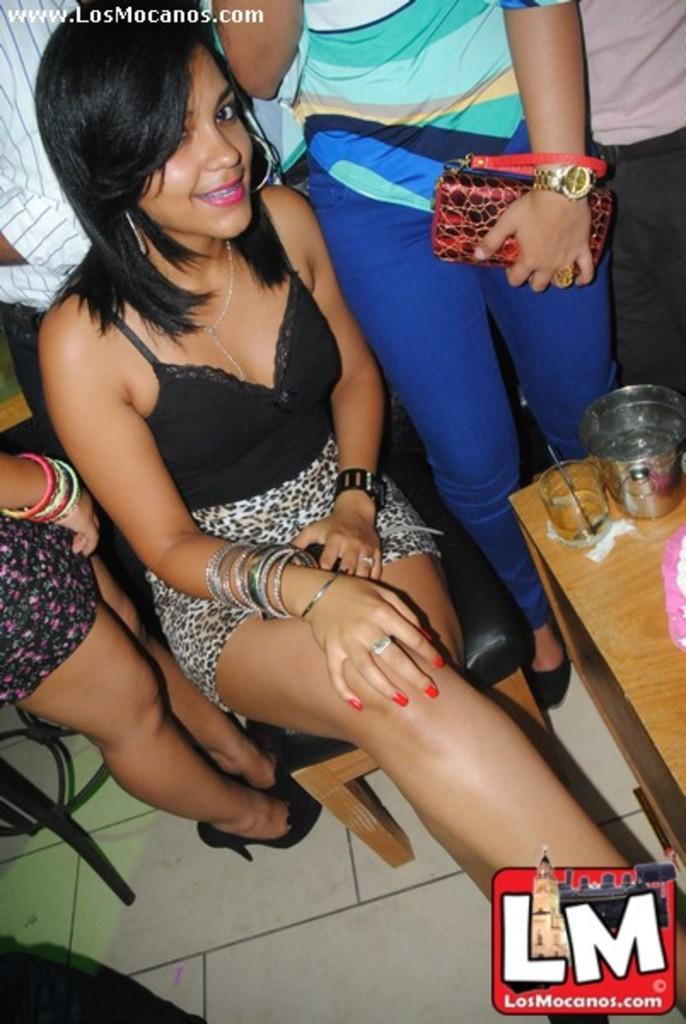What is the woman in the image doing? The woman is sitting on a chair in the image. What is located next to the woman? There is a table next to the woman. Can you describe the background of the image? There are people standing in the background of the image. What type of stitch is the woman using to sew the ground in the image? There is no stitch or ground present in the image; it features a woman sitting on a chair with a table next to her and people standing in the background. 